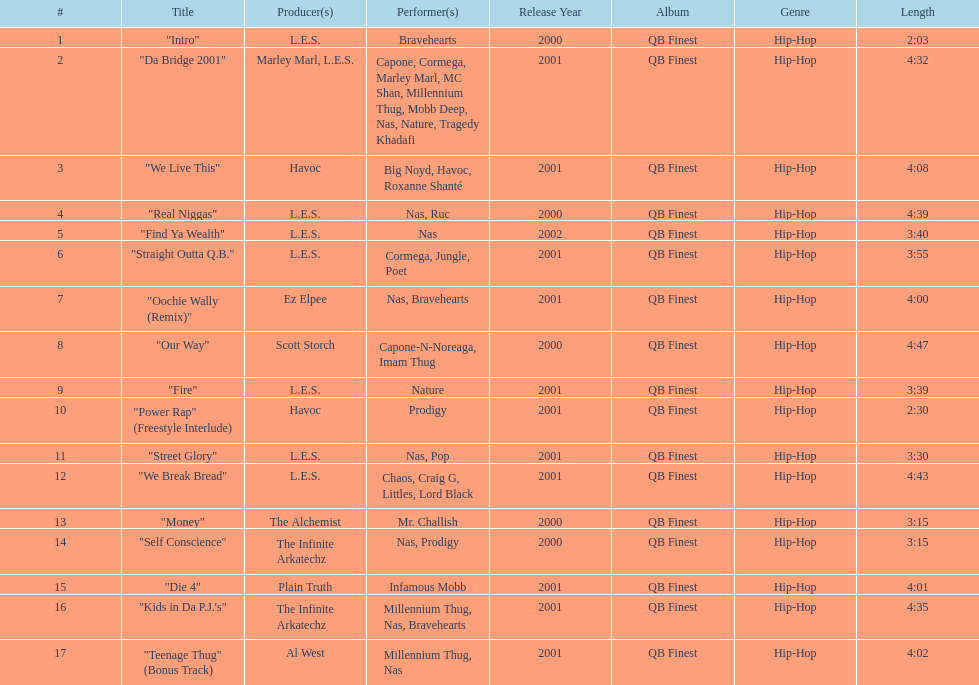What is the name of the last song on the album? "Teenage Thug" (Bonus Track). 